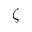Convert formula to latex. <formula><loc_0><loc_0><loc_500><loc_500>\zeta</formula> 